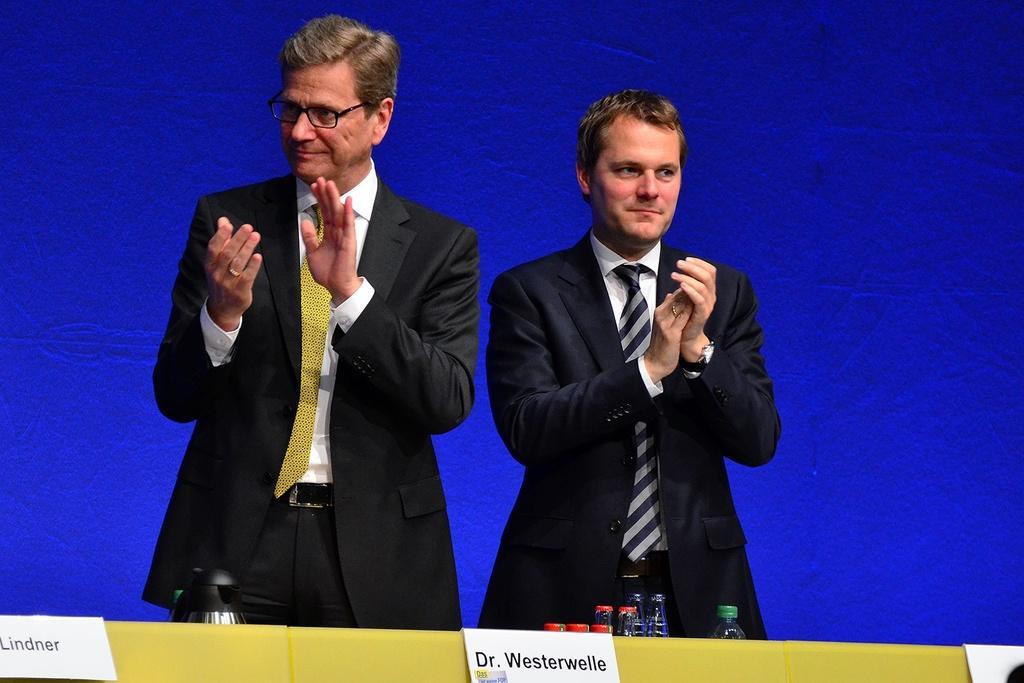How would you summarize this image in a sentence or two? In this image, we can see two men are standing and clapping. They are smiling. At the bottom, we can see name boards, bottles, lids, some object. Background we can see blue color. 